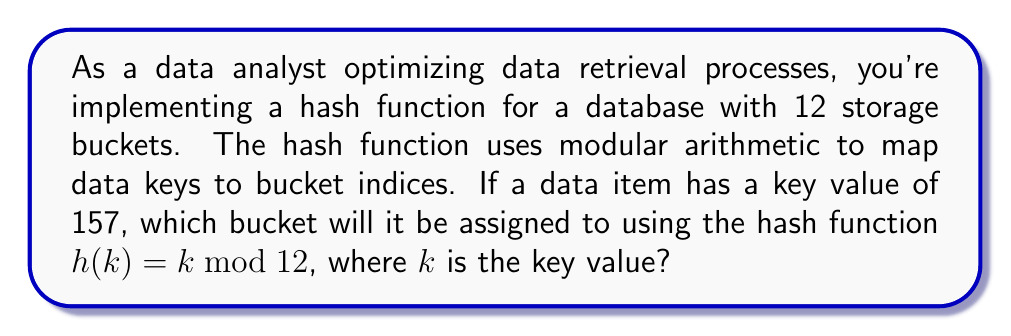Can you solve this math problem? To solve this problem, we need to apply the given hash function to the key value. The hash function is defined as:

$$h(k) = k \bmod 12$$

Where $k$ is the key value, and the result is the bucket index.

For our given key value $k = 157$, we perform the following steps:

1) First, we divide 157 by 12:
   $$157 \div 12 = 13 \text{ remainder } 1$$

2) The modulo operation returns the remainder of this division. So:
   $$157 \bmod 12 = 1$$

3) Therefore, $h(157) = 1$

This means that the data item with key 157 will be assigned to bucket index 1.

The modular arithmetic used here ensures that all possible key values are mapped to one of the 12 available buckets (indices 0 to 11). This hash function distributes data across the buckets, which can help in optimizing data retrieval by reducing the search space to a specific bucket.
Answer: $1$ 